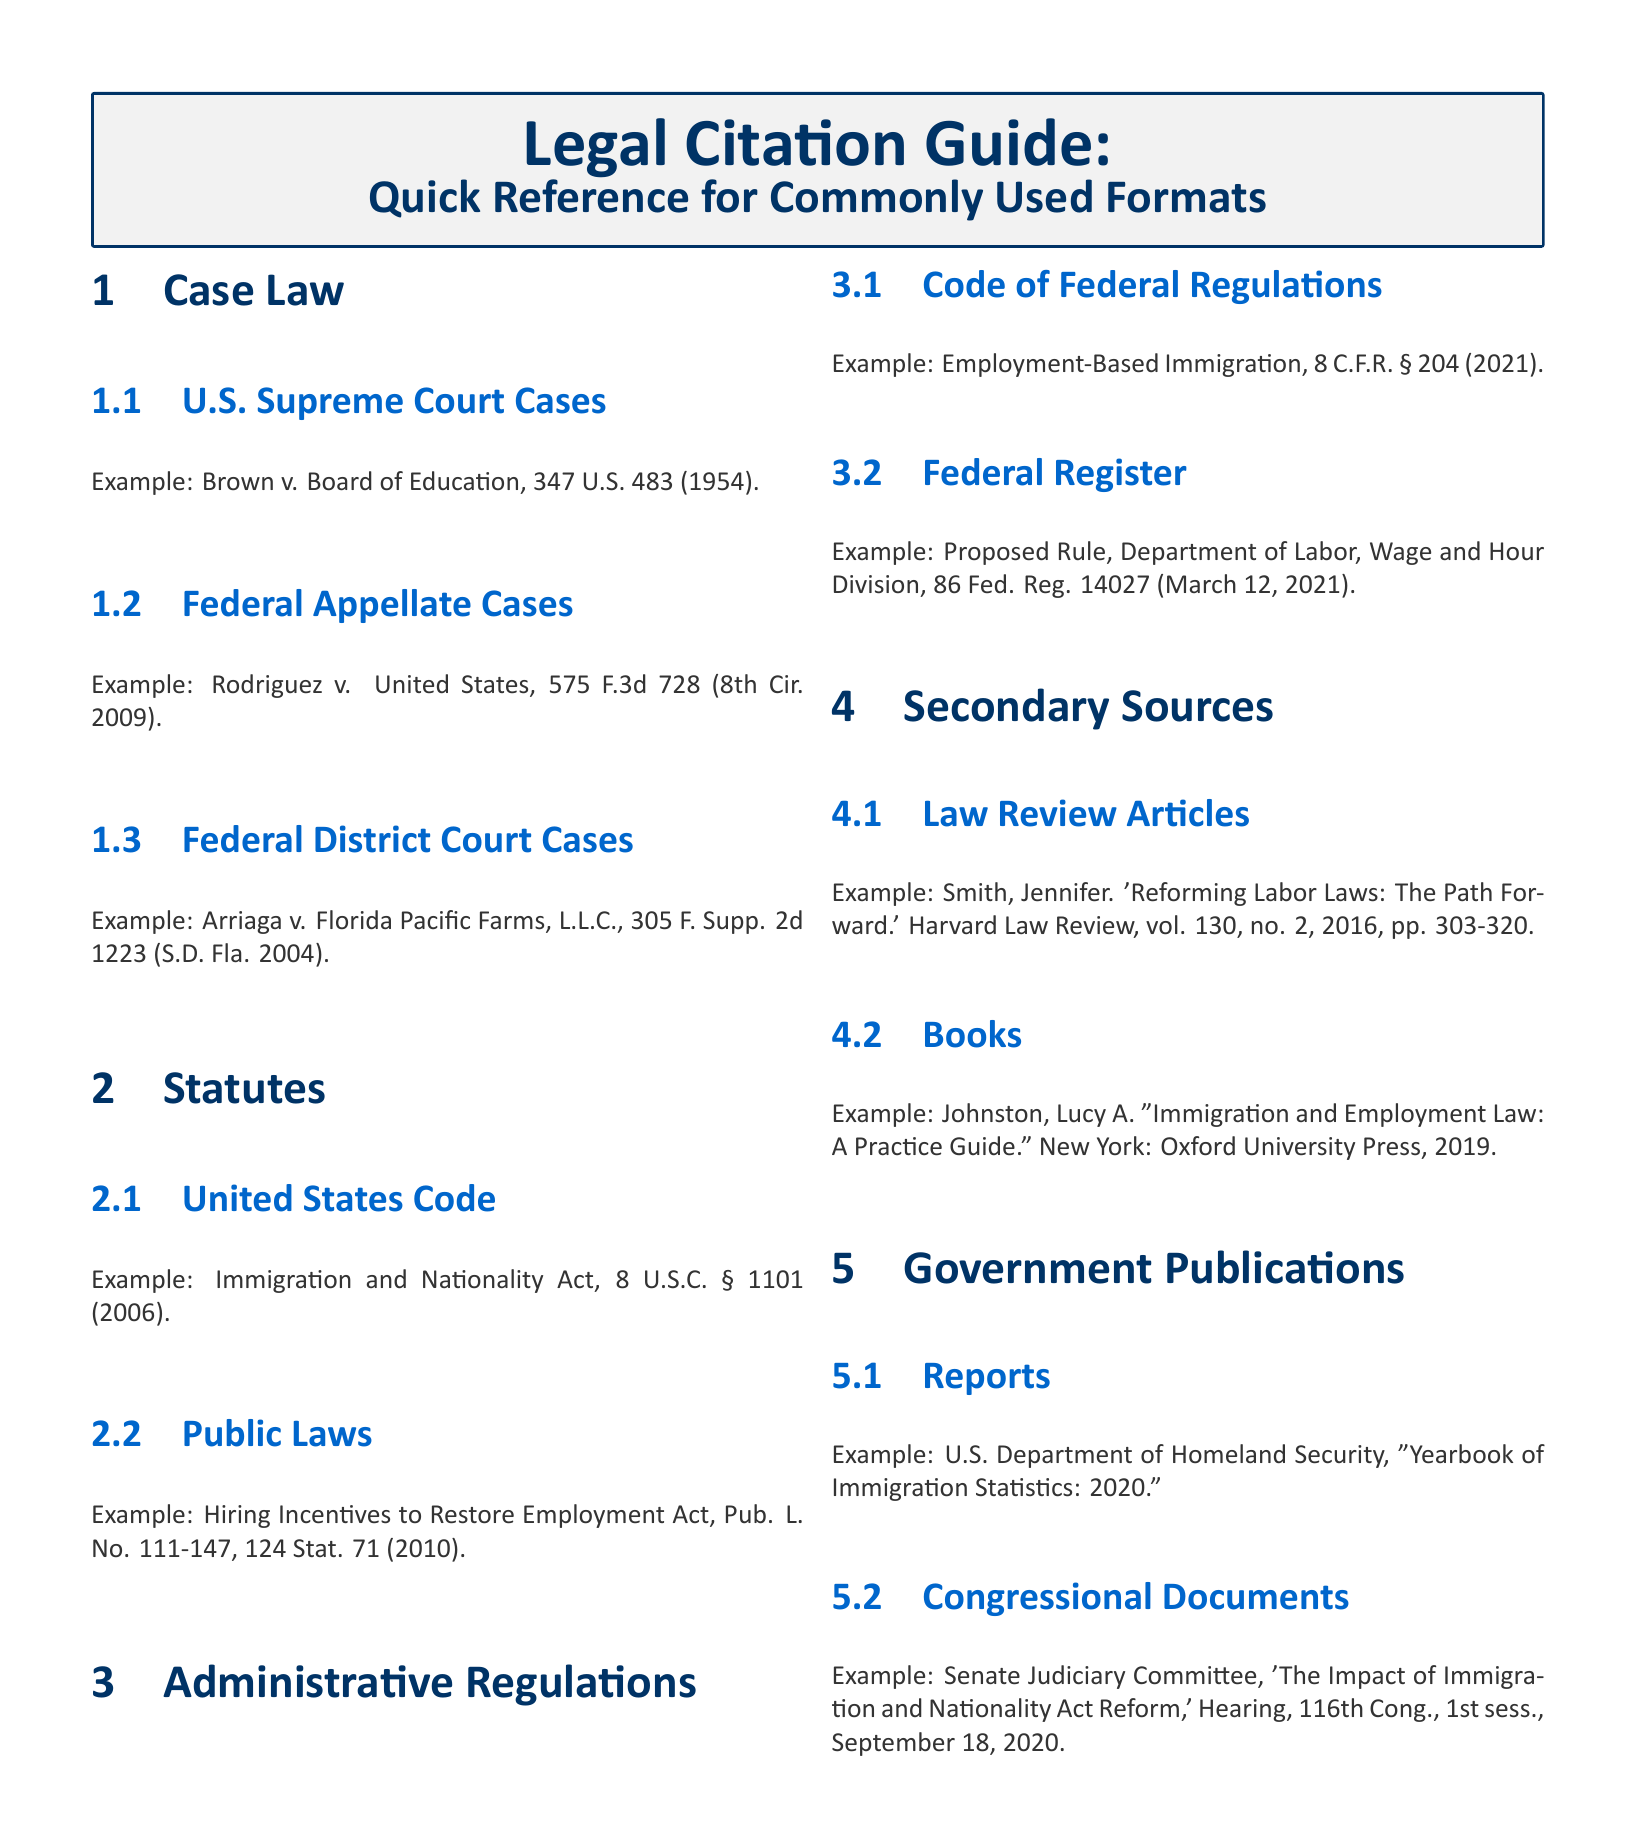What is the example case for U.S. Supreme Court Cases? The U.S. Supreme Court case example provided is "Brown v. Board of Education, 347 U.S. 483 (1954)."
Answer: Brown v. Board of Education, 347 U.S. 483 (1954) What is the format for Federal Appellate Cases? The format is shown in the example "Rodriguez v. United States, 575 F.3d 728 (8th Cir. 2009)."
Answer: Rodriguez v. United States, 575 F.3d 728 (8th Cir. 2009) What year was the Immigration and Nationality Act enacted? The Immigration and Nationality Act reference mentions the year as 2006.
Answer: 2006 What section covers the Code of Federal Regulations example? The example provided is "Employment-Based Immigration, 8 C.F.R. § 204 (2021)."
Answer: 8 C.F.R. § 204 (2021) Which document type includes a title related to labor laws? The document type is "Law Review Articles" with the title "Reforming Labor Laws: The Path Forward."
Answer: Law Review Articles What is the publication year of the book example given? The book reference includes the year 2019 as part of its citation.
Answer: 2019 What organization published the "Yearbook of Immigration Statistics: 2020"? The organization is the "U.S. Department of Homeland Security."
Answer: U.S. Department of Homeland Security What session of Congress held the hearing on the Impact of Immigration and Nationality Act Reform? The session mentioned is the "1st sess." of the "116th Cong."
Answer: 1st sess 